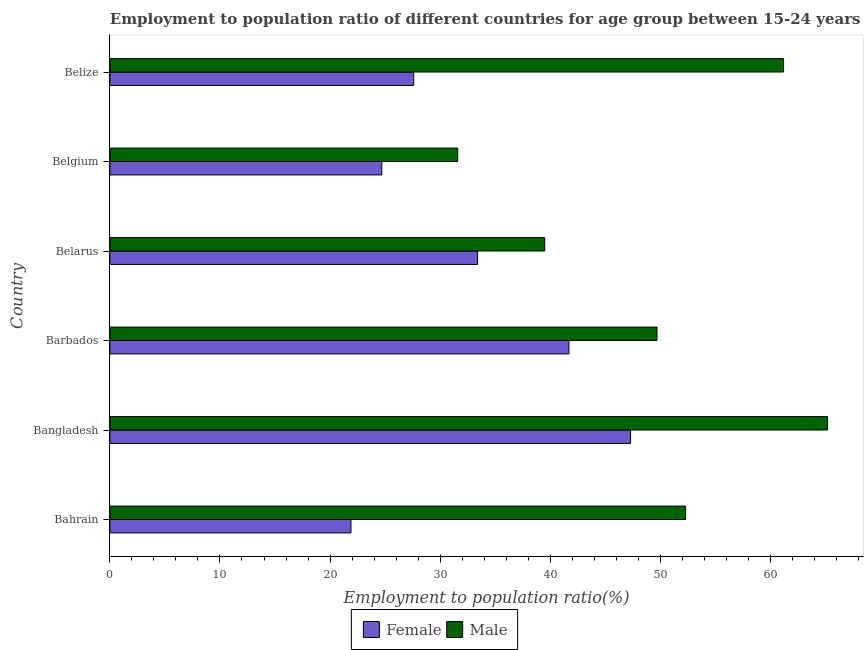How many different coloured bars are there?
Offer a terse response. 2. How many bars are there on the 1st tick from the top?
Your answer should be very brief. 2. How many bars are there on the 6th tick from the bottom?
Keep it short and to the point. 2. What is the label of the 6th group of bars from the top?
Offer a terse response. Bahrain. In how many cases, is the number of bars for a given country not equal to the number of legend labels?
Offer a very short reply. 0. What is the employment to population ratio(female) in Belgium?
Provide a short and direct response. 24.7. Across all countries, what is the maximum employment to population ratio(female)?
Your response must be concise. 47.3. Across all countries, what is the minimum employment to population ratio(male)?
Ensure brevity in your answer.  31.6. In which country was the employment to population ratio(female) maximum?
Make the answer very short. Bangladesh. In which country was the employment to population ratio(male) minimum?
Keep it short and to the point. Belgium. What is the total employment to population ratio(male) in the graph?
Your answer should be compact. 299.5. What is the difference between the employment to population ratio(male) in Bahrain and that in Belgium?
Give a very brief answer. 20.7. What is the difference between the employment to population ratio(female) in Bahrain and the employment to population ratio(male) in Barbados?
Your answer should be very brief. -27.8. What is the average employment to population ratio(female) per country?
Give a very brief answer. 32.77. What is the difference between the employment to population ratio(male) and employment to population ratio(female) in Bahrain?
Offer a very short reply. 30.4. What is the ratio of the employment to population ratio(male) in Bahrain to that in Belgium?
Offer a very short reply. 1.66. Is the employment to population ratio(male) in Bahrain less than that in Belize?
Ensure brevity in your answer.  Yes. What is the difference between the highest and the second highest employment to population ratio(male)?
Offer a terse response. 4. What is the difference between the highest and the lowest employment to population ratio(male)?
Your answer should be compact. 33.6. In how many countries, is the employment to population ratio(female) greater than the average employment to population ratio(female) taken over all countries?
Offer a very short reply. 3. Is the sum of the employment to population ratio(male) in Bahrain and Belize greater than the maximum employment to population ratio(female) across all countries?
Make the answer very short. Yes. What does the 1st bar from the top in Bangladesh represents?
Provide a short and direct response. Male. How many bars are there?
Your answer should be compact. 12. Are the values on the major ticks of X-axis written in scientific E-notation?
Your answer should be very brief. No. Does the graph contain grids?
Give a very brief answer. No. How many legend labels are there?
Offer a terse response. 2. What is the title of the graph?
Your answer should be very brief. Employment to population ratio of different countries for age group between 15-24 years. Does "Exports of goods" appear as one of the legend labels in the graph?
Make the answer very short. No. What is the label or title of the Y-axis?
Your answer should be very brief. Country. What is the Employment to population ratio(%) in Female in Bahrain?
Provide a short and direct response. 21.9. What is the Employment to population ratio(%) in Male in Bahrain?
Ensure brevity in your answer.  52.3. What is the Employment to population ratio(%) of Female in Bangladesh?
Give a very brief answer. 47.3. What is the Employment to population ratio(%) of Male in Bangladesh?
Keep it short and to the point. 65.2. What is the Employment to population ratio(%) of Female in Barbados?
Your answer should be very brief. 41.7. What is the Employment to population ratio(%) in Male in Barbados?
Your response must be concise. 49.7. What is the Employment to population ratio(%) of Female in Belarus?
Your answer should be very brief. 33.4. What is the Employment to population ratio(%) of Male in Belarus?
Offer a terse response. 39.5. What is the Employment to population ratio(%) in Female in Belgium?
Ensure brevity in your answer.  24.7. What is the Employment to population ratio(%) of Male in Belgium?
Provide a succinct answer. 31.6. What is the Employment to population ratio(%) of Female in Belize?
Your answer should be compact. 27.6. What is the Employment to population ratio(%) of Male in Belize?
Ensure brevity in your answer.  61.2. Across all countries, what is the maximum Employment to population ratio(%) of Female?
Your response must be concise. 47.3. Across all countries, what is the maximum Employment to population ratio(%) of Male?
Give a very brief answer. 65.2. Across all countries, what is the minimum Employment to population ratio(%) of Female?
Offer a terse response. 21.9. Across all countries, what is the minimum Employment to population ratio(%) of Male?
Make the answer very short. 31.6. What is the total Employment to population ratio(%) of Female in the graph?
Keep it short and to the point. 196.6. What is the total Employment to population ratio(%) of Male in the graph?
Your answer should be very brief. 299.5. What is the difference between the Employment to population ratio(%) in Female in Bahrain and that in Bangladesh?
Provide a short and direct response. -25.4. What is the difference between the Employment to population ratio(%) in Female in Bahrain and that in Barbados?
Your answer should be very brief. -19.8. What is the difference between the Employment to population ratio(%) of Male in Bahrain and that in Barbados?
Give a very brief answer. 2.6. What is the difference between the Employment to population ratio(%) in Female in Bahrain and that in Belarus?
Provide a short and direct response. -11.5. What is the difference between the Employment to population ratio(%) of Male in Bahrain and that in Belarus?
Provide a short and direct response. 12.8. What is the difference between the Employment to population ratio(%) in Male in Bahrain and that in Belgium?
Offer a very short reply. 20.7. What is the difference between the Employment to population ratio(%) of Female in Bangladesh and that in Barbados?
Give a very brief answer. 5.6. What is the difference between the Employment to population ratio(%) in Female in Bangladesh and that in Belarus?
Give a very brief answer. 13.9. What is the difference between the Employment to population ratio(%) of Male in Bangladesh and that in Belarus?
Make the answer very short. 25.7. What is the difference between the Employment to population ratio(%) in Female in Bangladesh and that in Belgium?
Provide a short and direct response. 22.6. What is the difference between the Employment to population ratio(%) of Male in Bangladesh and that in Belgium?
Provide a succinct answer. 33.6. What is the difference between the Employment to population ratio(%) of Female in Bangladesh and that in Belize?
Your answer should be compact. 19.7. What is the difference between the Employment to population ratio(%) of Male in Bangladesh and that in Belize?
Keep it short and to the point. 4. What is the difference between the Employment to population ratio(%) in Female in Barbados and that in Belarus?
Your answer should be compact. 8.3. What is the difference between the Employment to population ratio(%) of Male in Barbados and that in Belarus?
Provide a short and direct response. 10.2. What is the difference between the Employment to population ratio(%) of Male in Barbados and that in Belgium?
Offer a terse response. 18.1. What is the difference between the Employment to population ratio(%) of Male in Barbados and that in Belize?
Offer a very short reply. -11.5. What is the difference between the Employment to population ratio(%) of Female in Belarus and that in Belgium?
Your response must be concise. 8.7. What is the difference between the Employment to population ratio(%) of Male in Belarus and that in Belgium?
Offer a terse response. 7.9. What is the difference between the Employment to population ratio(%) in Male in Belarus and that in Belize?
Your response must be concise. -21.7. What is the difference between the Employment to population ratio(%) in Male in Belgium and that in Belize?
Your response must be concise. -29.6. What is the difference between the Employment to population ratio(%) in Female in Bahrain and the Employment to population ratio(%) in Male in Bangladesh?
Make the answer very short. -43.3. What is the difference between the Employment to population ratio(%) of Female in Bahrain and the Employment to population ratio(%) of Male in Barbados?
Your response must be concise. -27.8. What is the difference between the Employment to population ratio(%) in Female in Bahrain and the Employment to population ratio(%) in Male in Belarus?
Offer a terse response. -17.6. What is the difference between the Employment to population ratio(%) in Female in Bahrain and the Employment to population ratio(%) in Male in Belgium?
Ensure brevity in your answer.  -9.7. What is the difference between the Employment to population ratio(%) of Female in Bahrain and the Employment to population ratio(%) of Male in Belize?
Your answer should be very brief. -39.3. What is the difference between the Employment to population ratio(%) of Female in Bangladesh and the Employment to population ratio(%) of Male in Barbados?
Provide a succinct answer. -2.4. What is the difference between the Employment to population ratio(%) in Female in Bangladesh and the Employment to population ratio(%) in Male in Belarus?
Make the answer very short. 7.8. What is the difference between the Employment to population ratio(%) of Female in Bangladesh and the Employment to population ratio(%) of Male in Belgium?
Your answer should be compact. 15.7. What is the difference between the Employment to population ratio(%) in Female in Barbados and the Employment to population ratio(%) in Male in Belarus?
Your response must be concise. 2.2. What is the difference between the Employment to population ratio(%) of Female in Barbados and the Employment to population ratio(%) of Male in Belgium?
Your response must be concise. 10.1. What is the difference between the Employment to population ratio(%) of Female in Barbados and the Employment to population ratio(%) of Male in Belize?
Your answer should be very brief. -19.5. What is the difference between the Employment to population ratio(%) in Female in Belarus and the Employment to population ratio(%) in Male in Belize?
Your answer should be compact. -27.8. What is the difference between the Employment to population ratio(%) in Female in Belgium and the Employment to population ratio(%) in Male in Belize?
Your response must be concise. -36.5. What is the average Employment to population ratio(%) in Female per country?
Provide a succinct answer. 32.77. What is the average Employment to population ratio(%) of Male per country?
Offer a terse response. 49.92. What is the difference between the Employment to population ratio(%) in Female and Employment to population ratio(%) in Male in Bahrain?
Ensure brevity in your answer.  -30.4. What is the difference between the Employment to population ratio(%) in Female and Employment to population ratio(%) in Male in Bangladesh?
Your answer should be very brief. -17.9. What is the difference between the Employment to population ratio(%) in Female and Employment to population ratio(%) in Male in Belgium?
Your response must be concise. -6.9. What is the difference between the Employment to population ratio(%) in Female and Employment to population ratio(%) in Male in Belize?
Your response must be concise. -33.6. What is the ratio of the Employment to population ratio(%) of Female in Bahrain to that in Bangladesh?
Provide a succinct answer. 0.46. What is the ratio of the Employment to population ratio(%) in Male in Bahrain to that in Bangladesh?
Give a very brief answer. 0.8. What is the ratio of the Employment to population ratio(%) in Female in Bahrain to that in Barbados?
Offer a terse response. 0.53. What is the ratio of the Employment to population ratio(%) in Male in Bahrain to that in Barbados?
Keep it short and to the point. 1.05. What is the ratio of the Employment to population ratio(%) in Female in Bahrain to that in Belarus?
Keep it short and to the point. 0.66. What is the ratio of the Employment to population ratio(%) of Male in Bahrain to that in Belarus?
Your response must be concise. 1.32. What is the ratio of the Employment to population ratio(%) in Female in Bahrain to that in Belgium?
Offer a terse response. 0.89. What is the ratio of the Employment to population ratio(%) of Male in Bahrain to that in Belgium?
Your answer should be compact. 1.66. What is the ratio of the Employment to population ratio(%) of Female in Bahrain to that in Belize?
Ensure brevity in your answer.  0.79. What is the ratio of the Employment to population ratio(%) in Male in Bahrain to that in Belize?
Provide a succinct answer. 0.85. What is the ratio of the Employment to population ratio(%) in Female in Bangladesh to that in Barbados?
Provide a short and direct response. 1.13. What is the ratio of the Employment to population ratio(%) of Male in Bangladesh to that in Barbados?
Your response must be concise. 1.31. What is the ratio of the Employment to population ratio(%) in Female in Bangladesh to that in Belarus?
Provide a short and direct response. 1.42. What is the ratio of the Employment to population ratio(%) of Male in Bangladesh to that in Belarus?
Offer a very short reply. 1.65. What is the ratio of the Employment to population ratio(%) in Female in Bangladesh to that in Belgium?
Make the answer very short. 1.92. What is the ratio of the Employment to population ratio(%) of Male in Bangladesh to that in Belgium?
Your answer should be compact. 2.06. What is the ratio of the Employment to population ratio(%) in Female in Bangladesh to that in Belize?
Your answer should be very brief. 1.71. What is the ratio of the Employment to population ratio(%) of Male in Bangladesh to that in Belize?
Make the answer very short. 1.07. What is the ratio of the Employment to population ratio(%) in Female in Barbados to that in Belarus?
Ensure brevity in your answer.  1.25. What is the ratio of the Employment to population ratio(%) of Male in Barbados to that in Belarus?
Provide a succinct answer. 1.26. What is the ratio of the Employment to population ratio(%) in Female in Barbados to that in Belgium?
Make the answer very short. 1.69. What is the ratio of the Employment to population ratio(%) of Male in Barbados to that in Belgium?
Offer a terse response. 1.57. What is the ratio of the Employment to population ratio(%) in Female in Barbados to that in Belize?
Your response must be concise. 1.51. What is the ratio of the Employment to population ratio(%) of Male in Barbados to that in Belize?
Your answer should be compact. 0.81. What is the ratio of the Employment to population ratio(%) in Female in Belarus to that in Belgium?
Your answer should be very brief. 1.35. What is the ratio of the Employment to population ratio(%) in Female in Belarus to that in Belize?
Give a very brief answer. 1.21. What is the ratio of the Employment to population ratio(%) in Male in Belarus to that in Belize?
Provide a short and direct response. 0.65. What is the ratio of the Employment to population ratio(%) in Female in Belgium to that in Belize?
Offer a terse response. 0.89. What is the ratio of the Employment to population ratio(%) of Male in Belgium to that in Belize?
Your answer should be compact. 0.52. What is the difference between the highest and the lowest Employment to population ratio(%) of Female?
Your answer should be compact. 25.4. What is the difference between the highest and the lowest Employment to population ratio(%) in Male?
Keep it short and to the point. 33.6. 